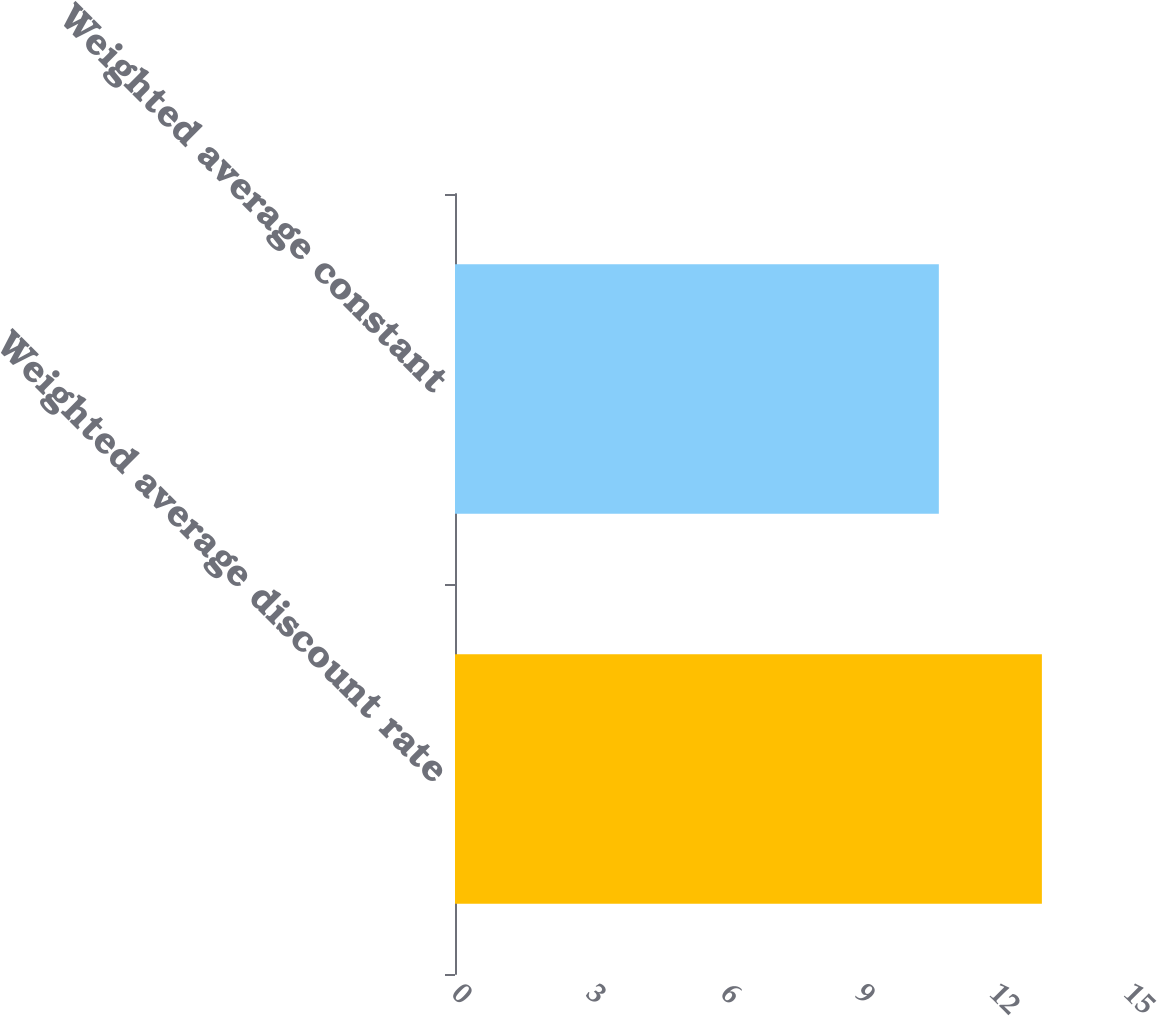Convert chart. <chart><loc_0><loc_0><loc_500><loc_500><bar_chart><fcel>Weighted average discount rate<fcel>Weighted average constant<nl><fcel>13.1<fcel>10.8<nl></chart> 